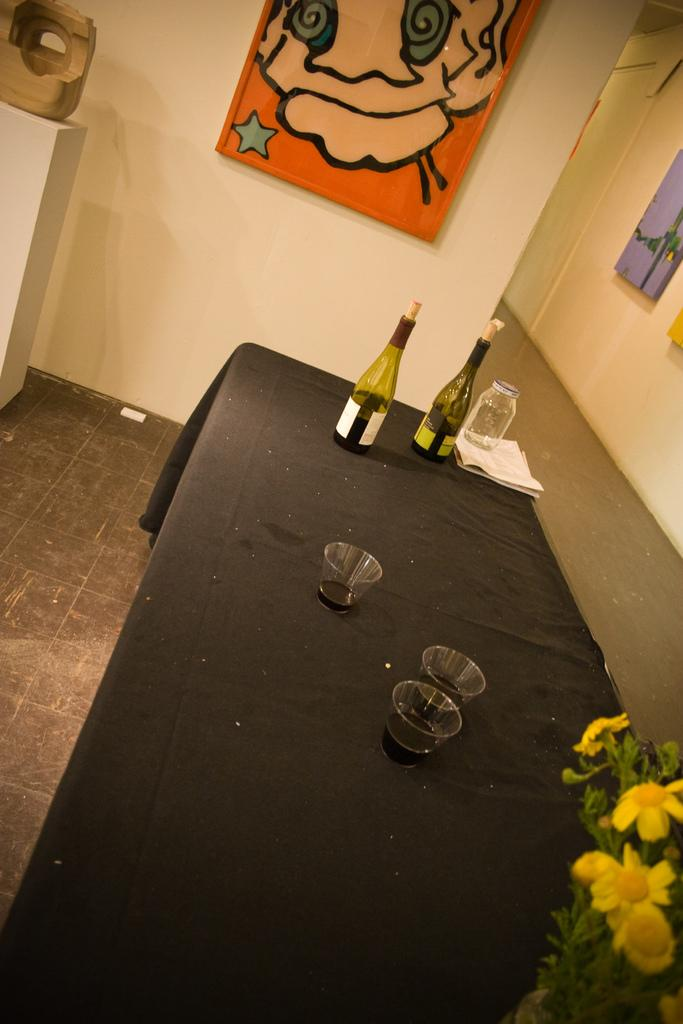What type of beverage containers are present in the image? There are wine bottles in the image. What can be found on the table in the image? There are glasses on the table in the image. What is hanging on the wall in the image? There is a photo frame on the wall in the image. How does the brake system work in the image? There is no brake system present in the image; it features wine bottles, glasses, and a photo frame. 